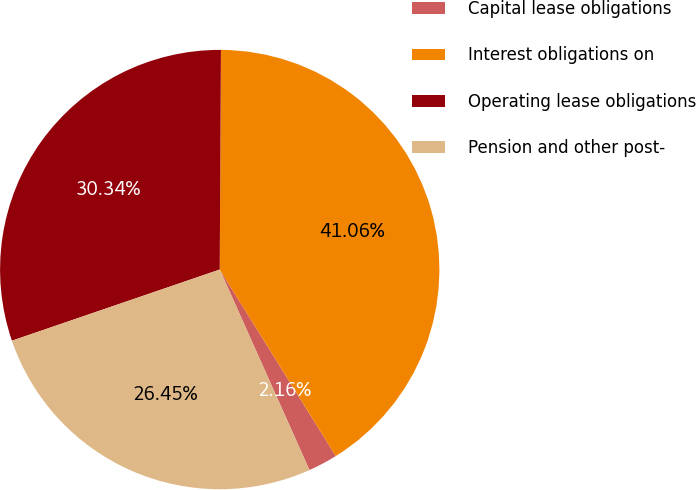Convert chart to OTSL. <chart><loc_0><loc_0><loc_500><loc_500><pie_chart><fcel>Capital lease obligations<fcel>Interest obligations on<fcel>Operating lease obligations<fcel>Pension and other post-<nl><fcel>2.16%<fcel>41.06%<fcel>30.34%<fcel>26.45%<nl></chart> 